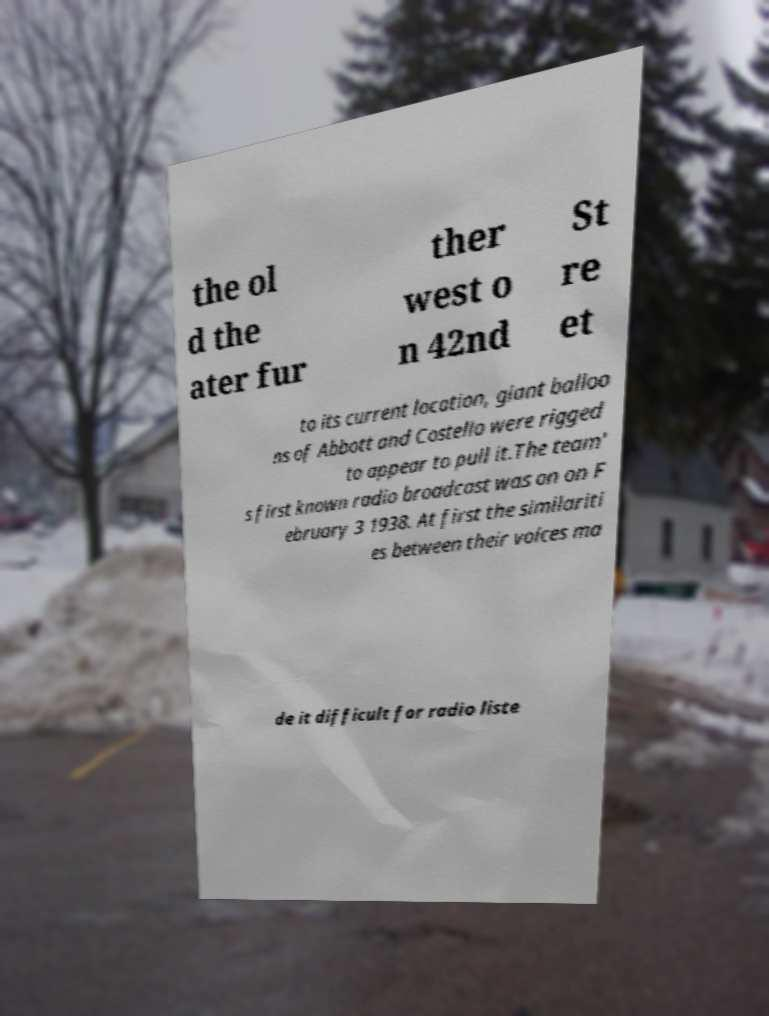Please read and relay the text visible in this image. What does it say? the ol d the ater fur ther west o n 42nd St re et to its current location, giant balloo ns of Abbott and Costello were rigged to appear to pull it.The team' s first known radio broadcast was on on F ebruary 3 1938. At first the similariti es between their voices ma de it difficult for radio liste 